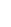Convert formula to latex. <formula><loc_0><loc_0><loc_500><loc_500>&</formula> 